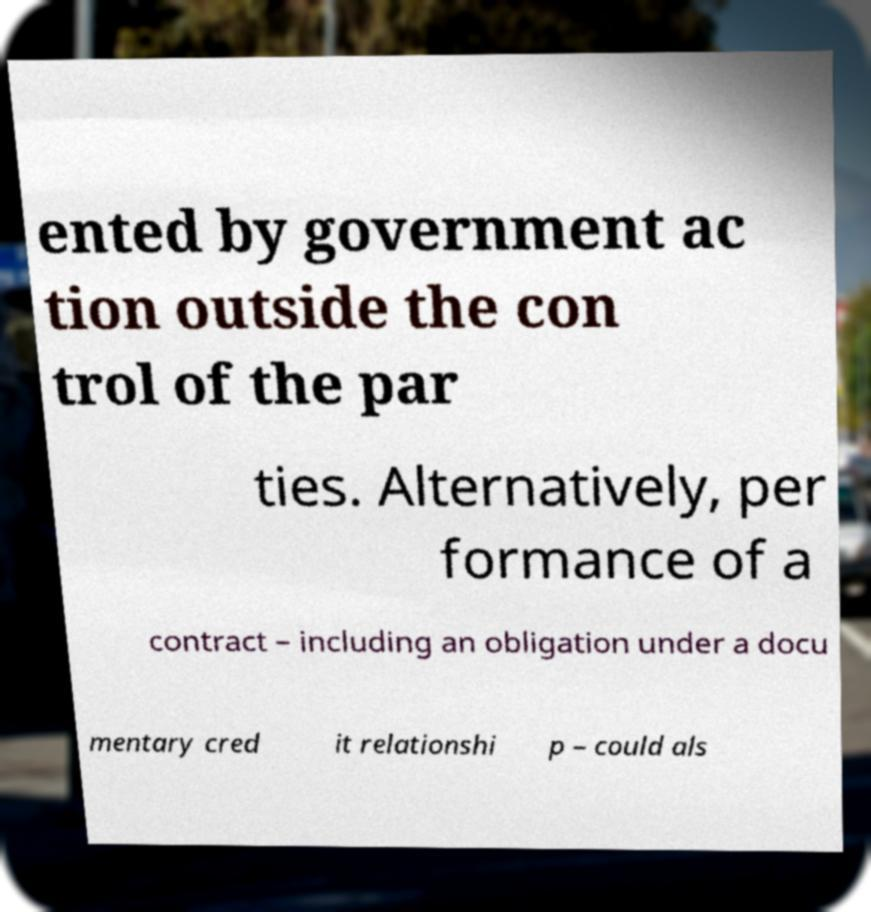Could you assist in decoding the text presented in this image and type it out clearly? ented by government ac tion outside the con trol of the par ties. Alternatively, per formance of a contract – including an obligation under a docu mentary cred it relationshi p – could als 